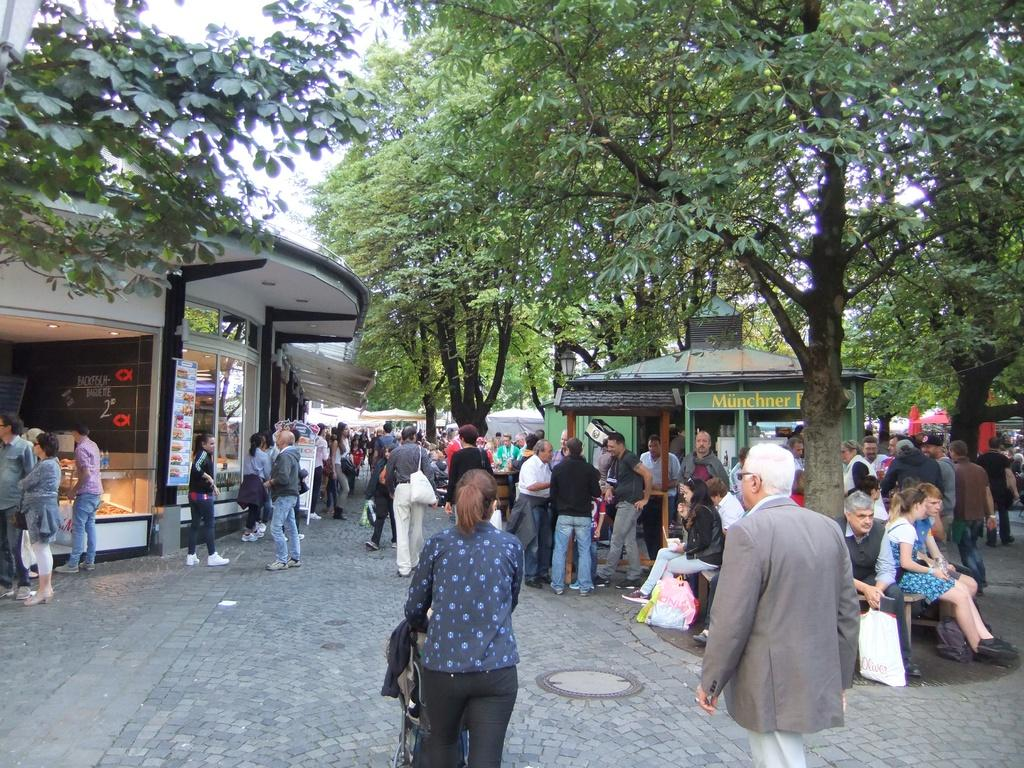What can be seen at the bottom of the image? There is a group of persons standing at the bottom of the image. What structure is located on the left side of the image? There is a building on the left side of the image. What type of natural elements can be seen in the background of the image? There are some trees in the background of the image. What type of representative can be seen in the image? There is no representative present in the image; it features a group of persons standing at the bottom and a building on the left side. Can you hear any thunder in the image? There is no sound present in the image, so it is not possible to determine if there is thunder. 